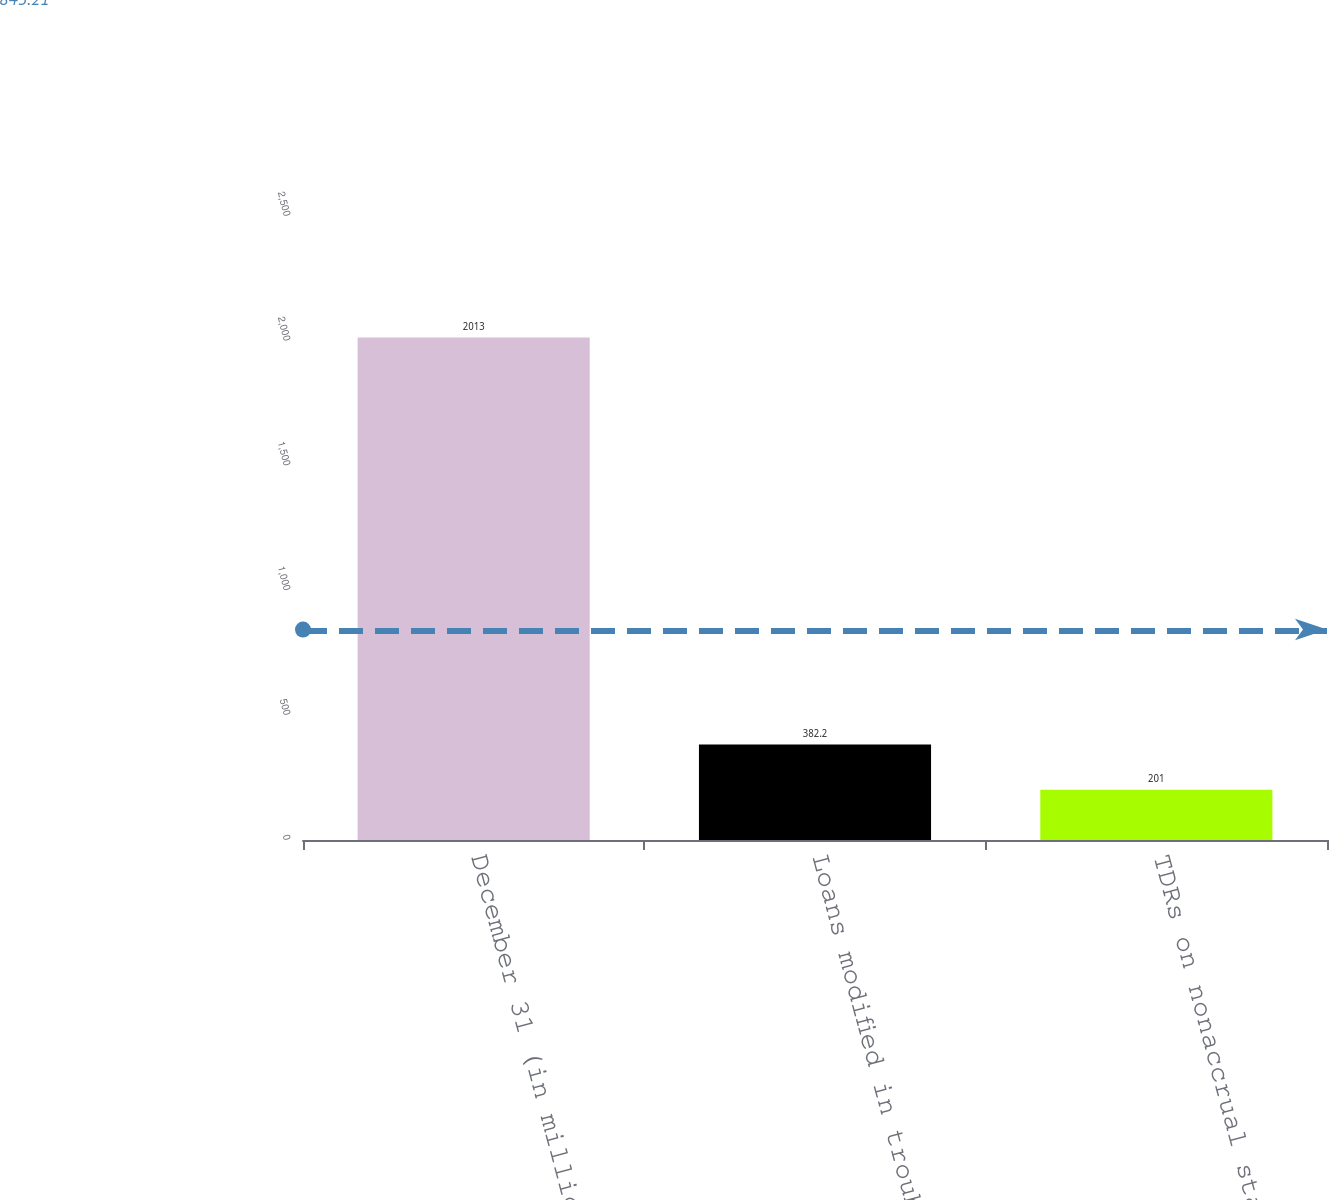Convert chart. <chart><loc_0><loc_0><loc_500><loc_500><bar_chart><fcel>December 31 (in millions)<fcel>Loans modified in troubled<fcel>TDRs on nonaccrual status<nl><fcel>2013<fcel>382.2<fcel>201<nl></chart> 